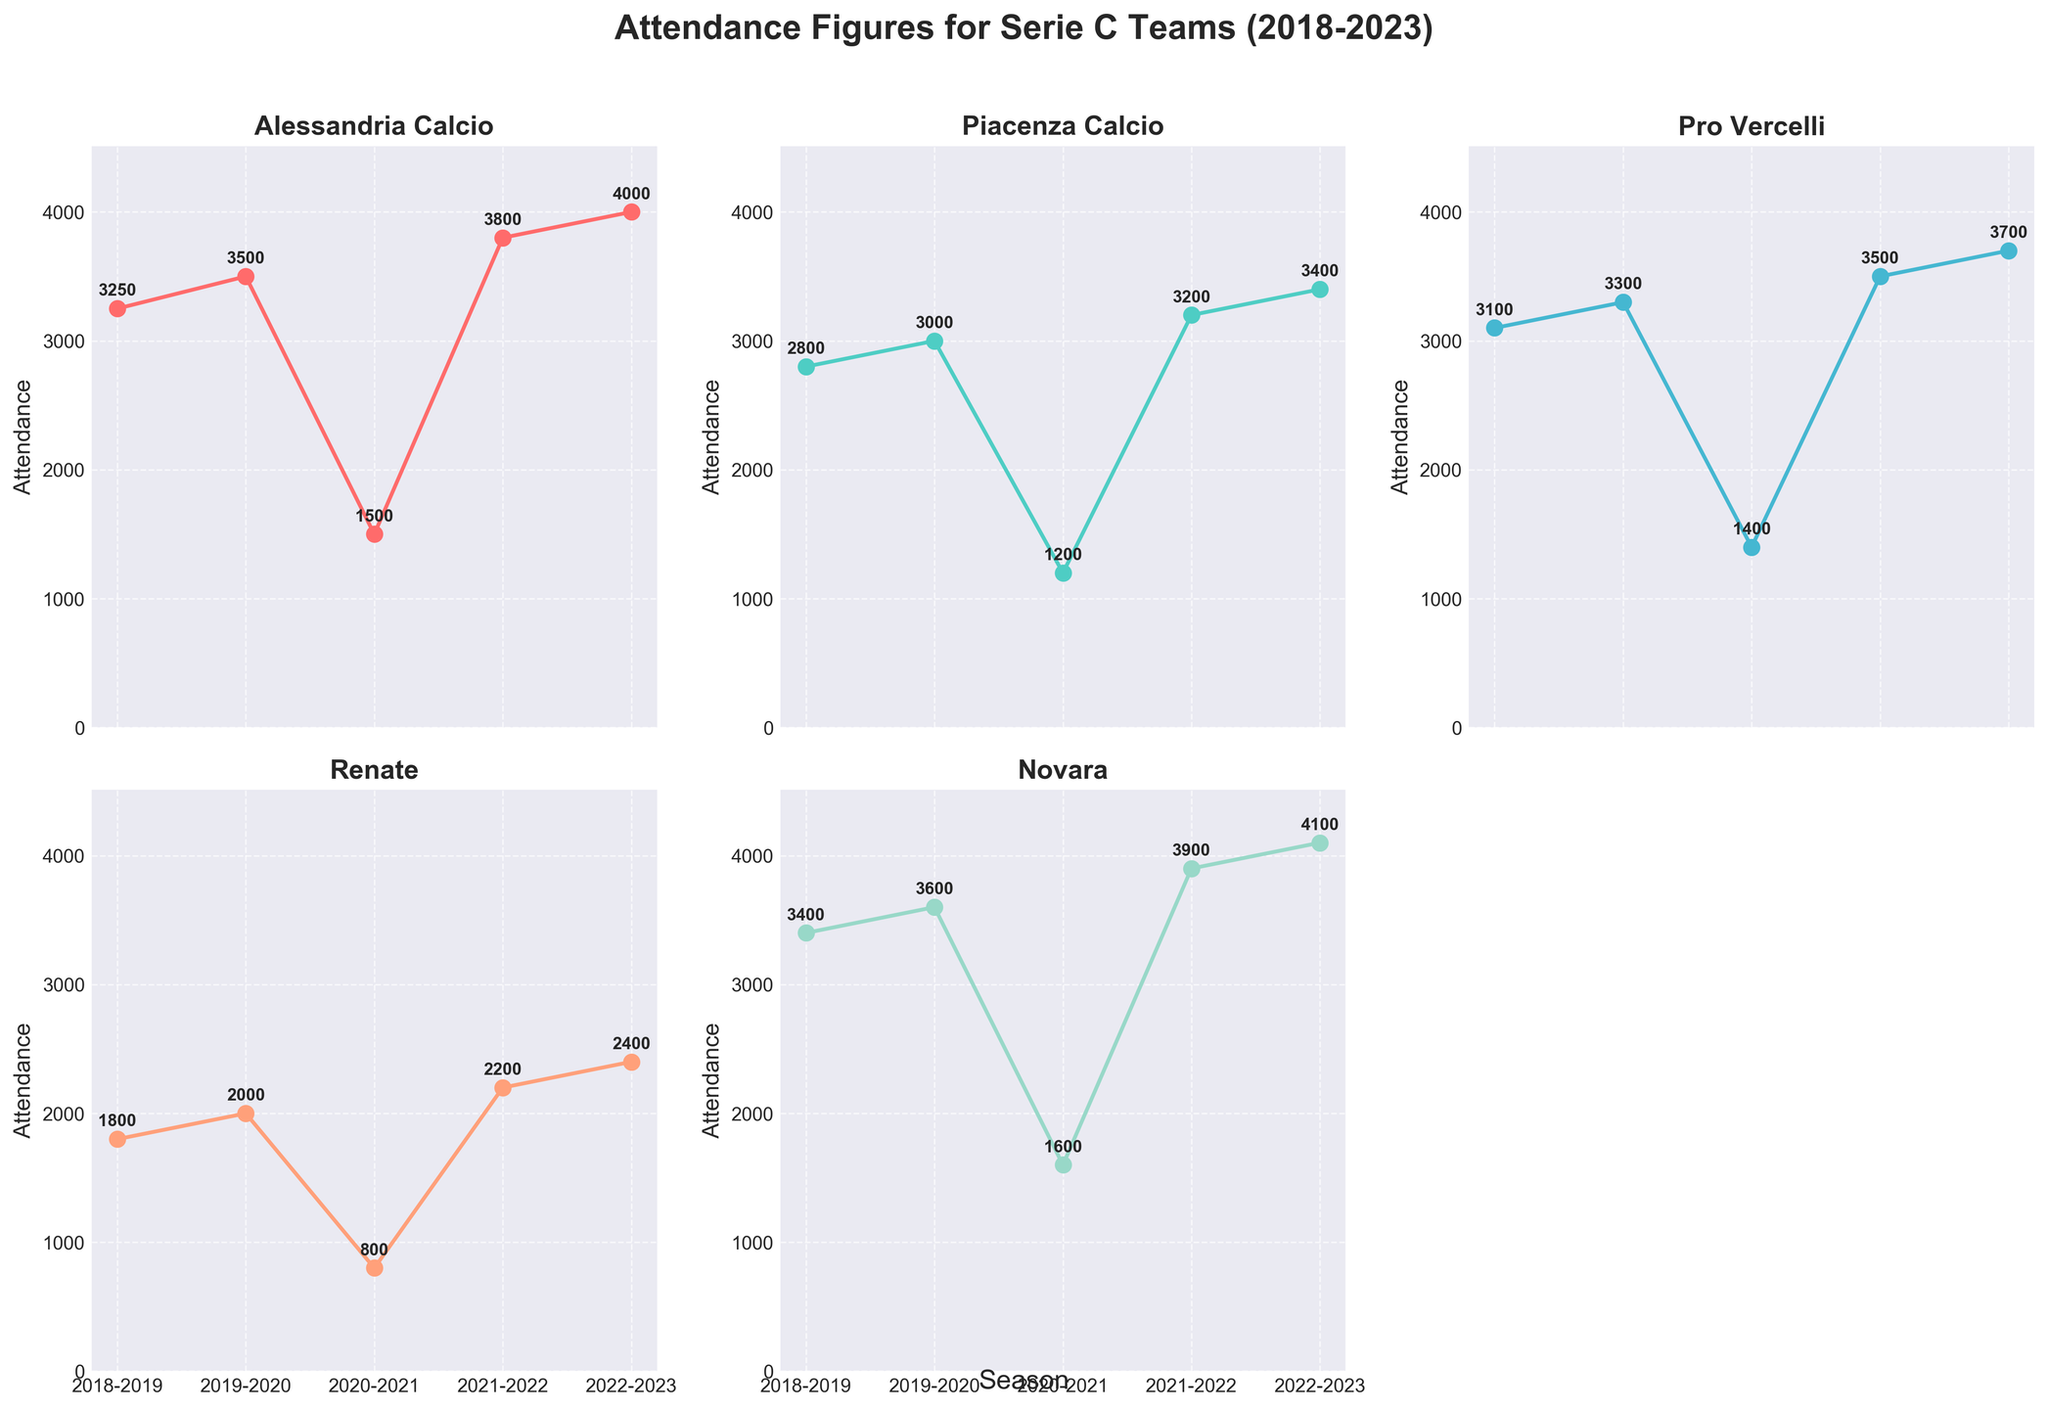What is the title of the figure? The title of the figure is positioned at the top center and is in bold text, indicating the main subject of the plot.
Answer: Attendance Figures for Serie C Teams (2018-2023) How many teams' attendance figures are shown in the subplots? By counting the individual title for each subplot, you can see there are titles for Alessandria Calcio, Piacenza Calcio, Pro Vercelli, Renate, and Novara.
Answer: 5 Which team had the lowest attendance in the 2018-2019 season? Looking at the y-values plotted for each team in the 2018-2019 season, Renate has the lowest point, indicating the lowest attendance value on the y-axis.
Answer: Renate How did attendance for Alessandria Calcio change from the 2020-2021 season to the 2021-2022 season? The figure shows the attendance for Alessandria Calcio in the 2020-2021 season was 1500, which increased to 3800 in the 2021-2022 season.
Answer: Increased Compare the attendance trends of Alessandria Calcio and Novara. Which team had higher attendance in more seasons? We compare each point in the plots by checking the y-values for each season. Alessandria Calcio had higher values in 2018-2019 and 2020-2021, whereas Novara had higher values in 2019-2020, 2021-2022, and 2022-2023.
Answer: Novara What was the highest attendance figure recorded, and for which team and season? By observing the plots, the highest y-value appears in Novara’s subplot in the 2022-2023 season with an attendance figure of 4100.
Answer: 4100, Novara, 2022-2023 Which seasons showed the same attendance value for at least two teams, if any? Checking all the plots for common attendance points, no two teams have exactly the same y-value marker in any season.
Answer: None Among the teams, which one showed a consistent increase in attendance over the seasons? Looking at the trend lines, we observe that Alessandria Calcio consistently increased its attendance over all seasons shown.
Answer: Alessandria Calcio What is the average attendance for Piacenza Calcio over the last five seasons? The attendance values are 2800, 3000, 1200, 3200, and 3400. Summing these gives 13600, then divided by 5 gives 2720.
Answer: 2720 Did any team experience a decrease in attendance in any consecutive seasons? If so, identify the team and seasons. Observing the plots, Pro Vercelli experienced a decrease from 2019-2020 (3300) to 2020-2021 (1400).
Answer: Pro Vercelli, 2019-2020 to 2020-2021 